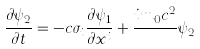Convert formula to latex. <formula><loc_0><loc_0><loc_500><loc_500>\frac { \partial \psi _ { 2 } } { \partial t } = - c \sigma _ { i } \frac { \partial \psi _ { 1 } } { \partial x ^ { i } } + \frac { i m _ { 0 } c ^ { 2 } } { } \psi _ { 2 }</formula> 